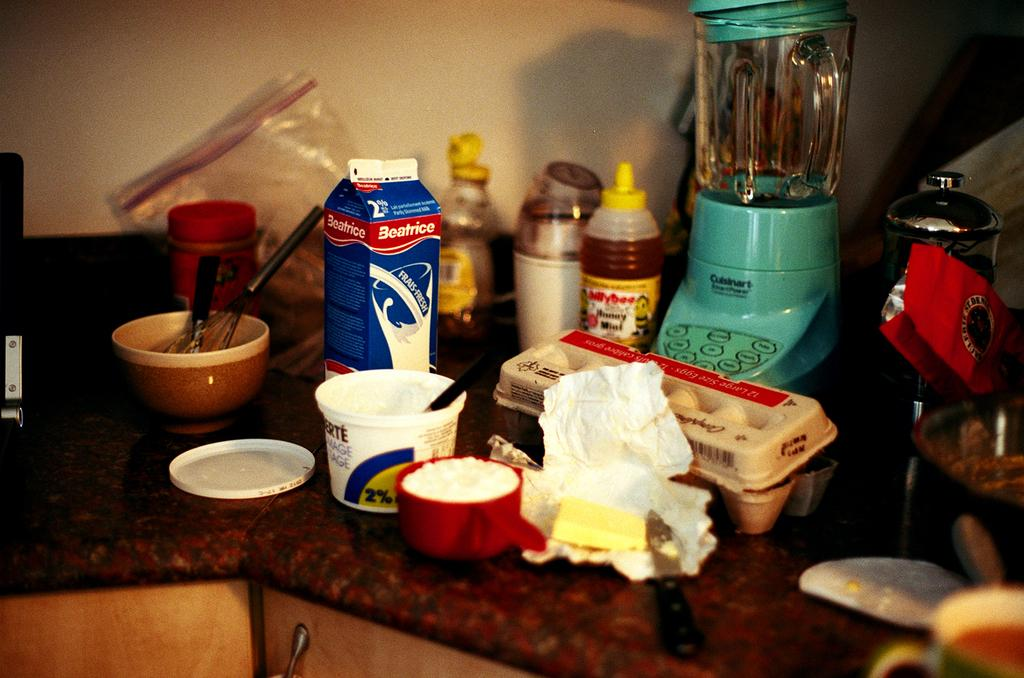<image>
Provide a brief description of the given image. A container of Beatrice milk sits on a messy counter full of food. 